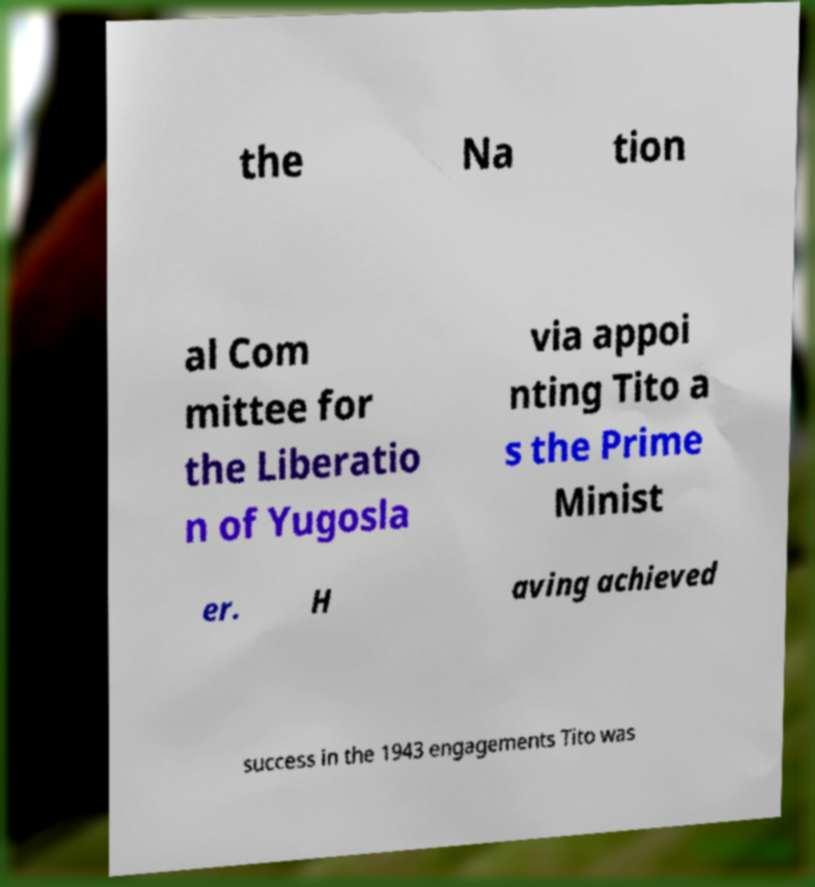I need the written content from this picture converted into text. Can you do that? the Na tion al Com mittee for the Liberatio n of Yugosla via appoi nting Tito a s the Prime Minist er. H aving achieved success in the 1943 engagements Tito was 